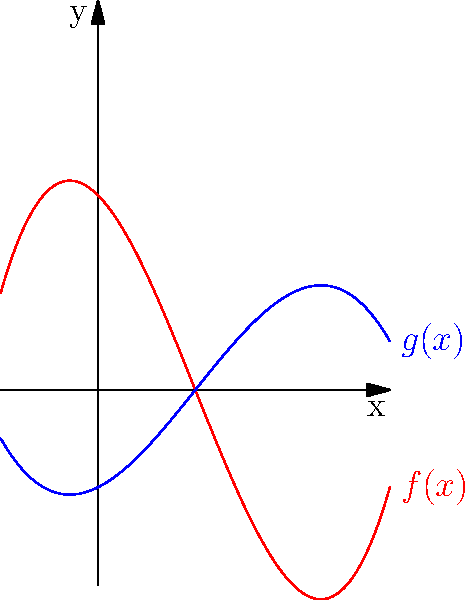In the graph above, two polynomial functions $f(x)$ and $g(x)$ are shown, representing different color gradients for an LED installation. If these functions control the intensity of red and blue lights respectively, at which x-coordinate would the installation appear purple (equal intensities of red and blue)? To find where the installation appears purple, we need to determine where the red and blue intensities are equal. This occurs at the intersection point of $f(x)$ and $g(x)$.

Step 1: Set up the equation $f(x) = g(x)$
$$(0.5x^3 - 1.5x^2 - x + 2) = (-0.25x^3 + 0.75x^2 + 0.5x - 1)$$

Step 2: Rearrange the equation
$$0.75x^3 - 2.25x^2 - 1.5x + 3 = 0$$

Step 3: Factor out the greatest common factor
$$0.75(x^3 - 3x^2 - 2x + 4) = 0$$

Step 4: Factor the cubic equation
$$0.75(x - 2)(x^2 - x - 2) = 0$$
$$0.75(x - 2)(x + 1)(x - 2) = 0$$

Step 5: Solve for x
The solutions are $x = 2$ (twice) and $x = -1$. However, $x = -1$ is outside our domain of interest.

Step 6: Verify the solution
At $x = 2$, both $f(2)$ and $g(2)$ equal 0, confirming this is the intersection point.

Therefore, the installation will appear purple at $x = 2$.
Answer: $x = 2$ 